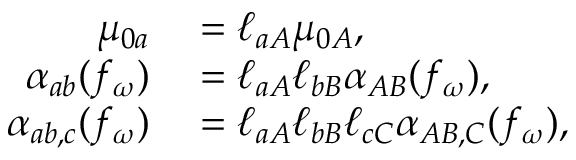<formula> <loc_0><loc_0><loc_500><loc_500>\begin{array} { r l } { \mu _ { 0 a } } & = \ell _ { a A } \mu _ { 0 A } , } \\ { \alpha _ { a b } ( f _ { \omega } ) } & = \ell _ { a A } \ell _ { b B } \alpha _ { A B } ( f _ { \omega } ) , } \\ { \alpha _ { a b , c } ( f _ { \omega } ) } & = \ell _ { a A } \ell _ { b B } \ell _ { c C } \alpha _ { A B , C } ( f _ { \omega } ) , } \end{array}</formula> 